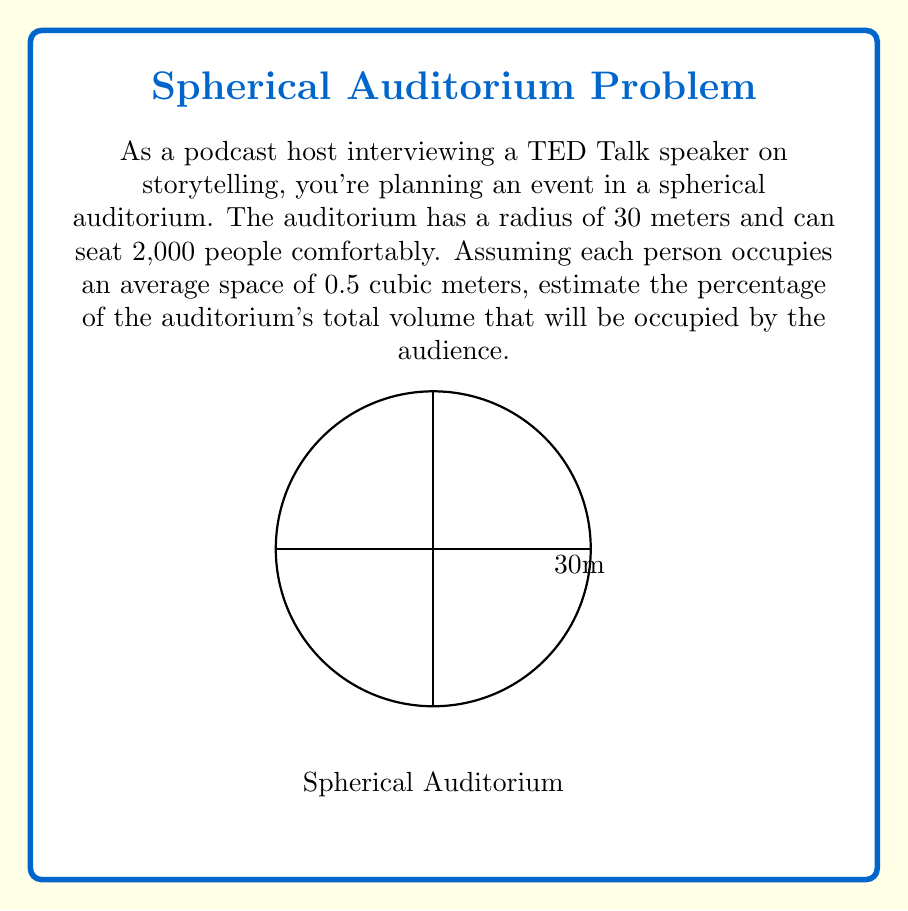Solve this math problem. Let's approach this step-by-step:

1) First, we need to calculate the volume of the spherical auditorium:
   The volume of a sphere is given by the formula: $V = \frac{4}{3}\pi r^3$
   
   $V = \frac{4}{3}\pi (30)^3 = \frac{4}{3}\pi (27000) \approx 113097.33$ cubic meters

2) Now, let's calculate the volume occupied by the audience:
   Each person occupies 0.5 cubic meters, and there are 2,000 people.
   
   $V_{audience} = 0.5 \times 2000 = 1000$ cubic meters

3) To find the percentage of the auditorium's volume occupied by the audience, we use:
   $\text{Percentage} = \frac{V_{audience}}{V_{total}} \times 100\%$

   $\text{Percentage} = \frac{1000}{113097.33} \times 100\% \approx 0.884\%$

Therefore, the audience will occupy approximately 0.884% of the auditorium's total volume.
Answer: $$0.884\%$$ 